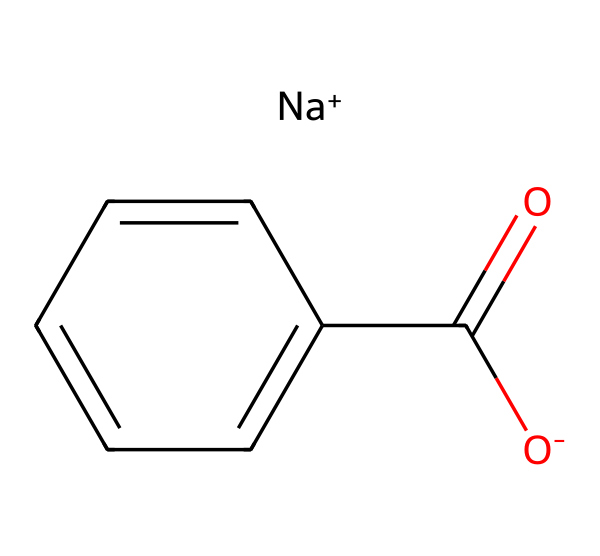What is the main functional group in this chemical? The chemical contains a carboxylate group represented by [O-]C(=O), which indicates it has a carboxylic acid derivative.
Answer: carboxylate How many carbon atoms are in this molecule? By examining the SMILES representation, we can see one carbon in the carboxylate group and five in the aromatic ring, totaling six carbon atoms.
Answer: six What type of ion is present in this chemical? The notation [Na+] indicates a sodium ion, which is a monovalent cation commonly used in food additives.
Answer: sodium ion What is the role of this chemical in food products? This chemical acts as a preservative, particularly for its ability to act against microbial growth due to the presence of the carboxylate group that can disrupt microbial cellular processes.
Answer: preservative How many oxygen atoms are present in this compound? In the SMILES notation, there are two oxygen atoms in the carboxylate group ([O-]C(=O)) and one in the aromatic ring, totaling three oxygen atoms.
Answer: three 